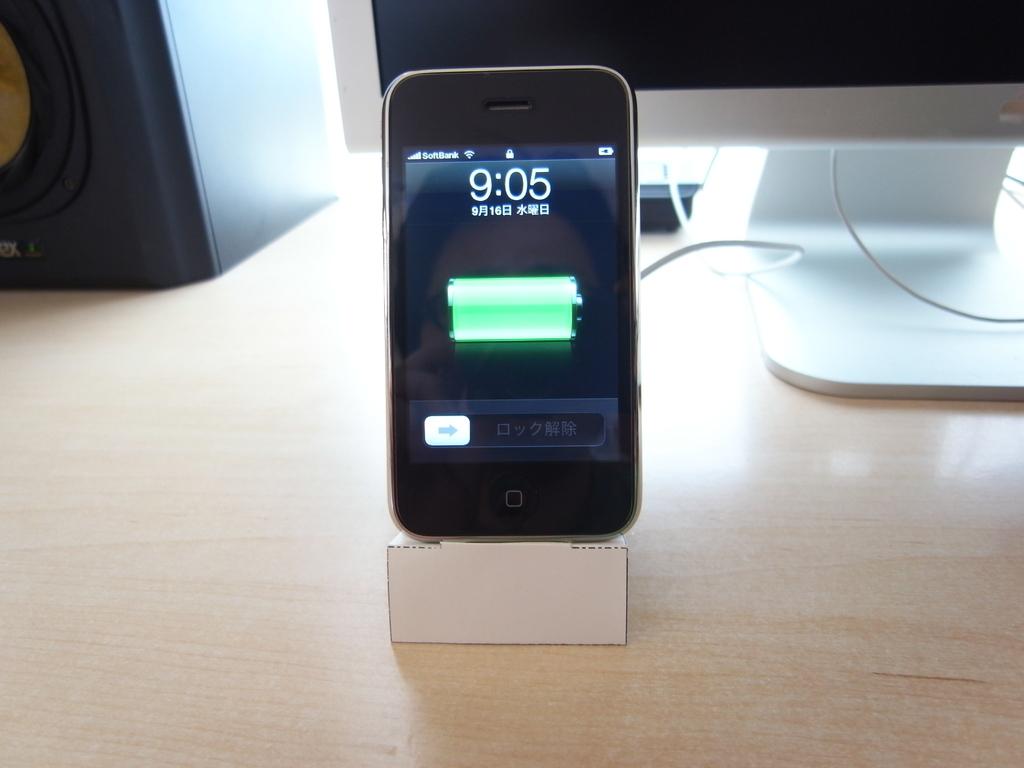Isn't that an iphone 4?
Offer a very short reply. Unanswerable. What time is it?
Your answer should be compact. 9:05. 